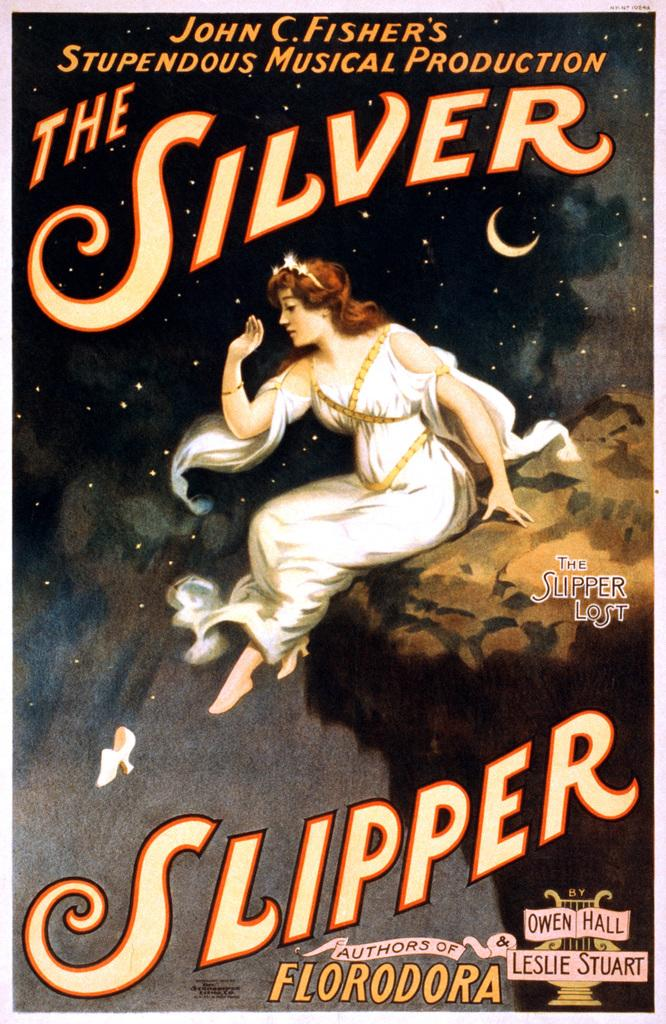<image>
Create a compact narrative representing the image presented. John C. Fisher produced the Silver Fisher by Hall and Stuart. 